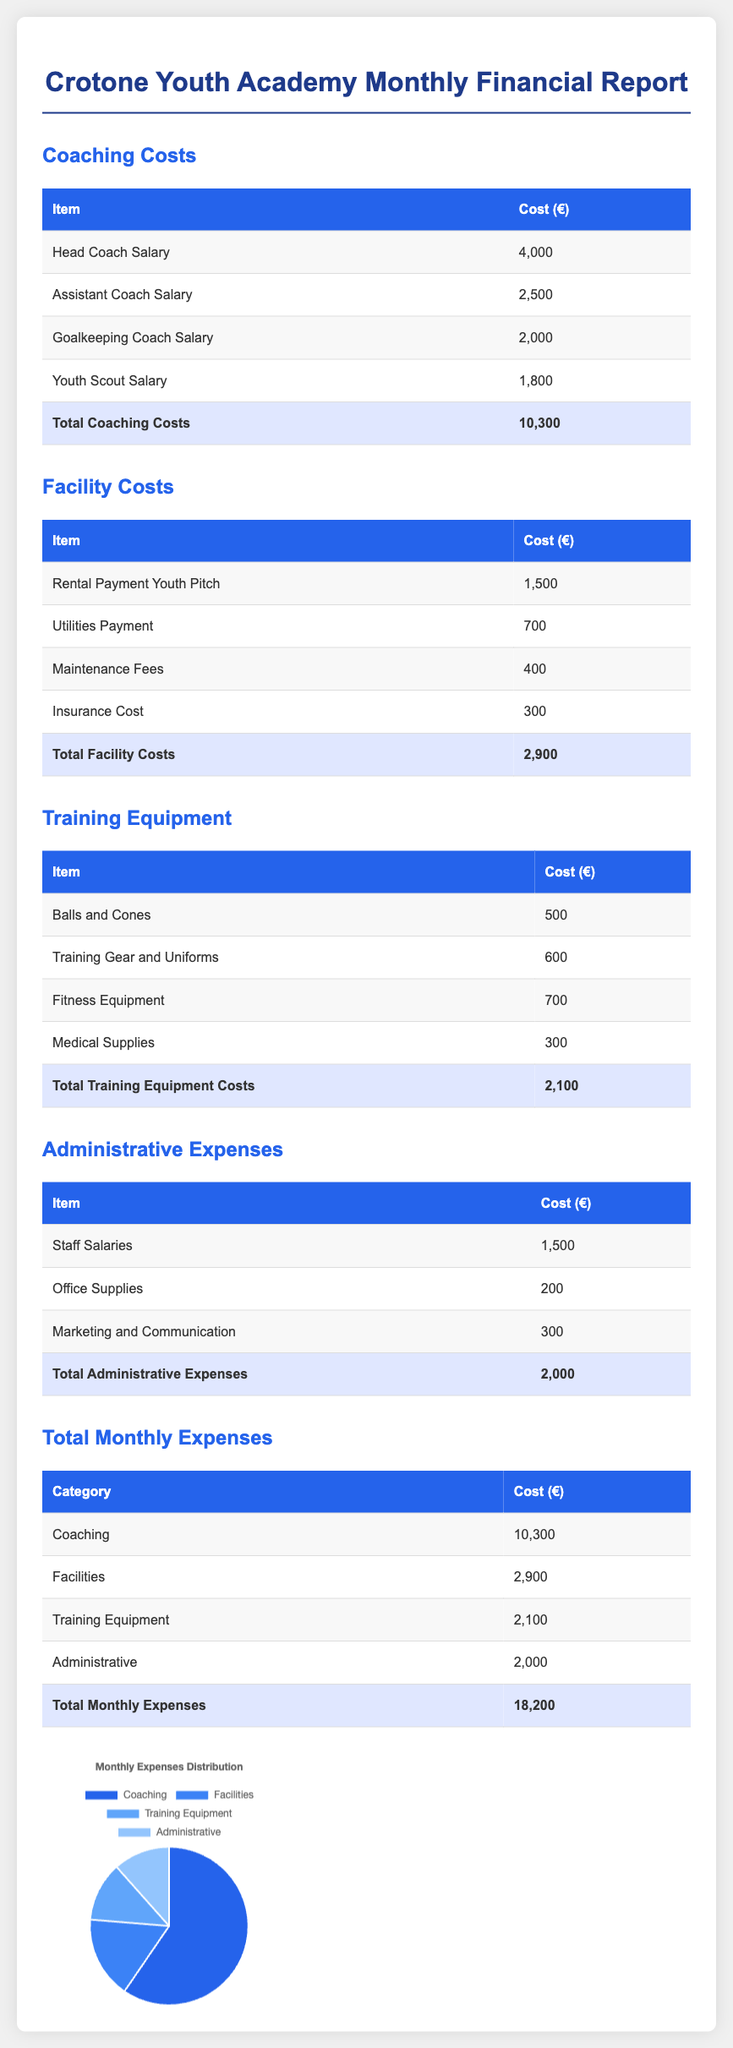What are the total coaching costs? The total coaching costs are detailed in the coaching costs section of the document, which lists all individual coaching expenses.
Answer: 10,300 What is the cost for the head coach's salary? The head coach's salary is listed under coaching costs, which specifically mentions the salary amount.
Answer: 4,000 How much does the youth academy spend on facilities? The total facility costs are summed up in the facilities section, providing the overall expense for facilities.
Answer: 2,900 What is the total cost for training equipment? The total training equipment costs are aggregated in the training equipment section, showing the overall expenditure.
Answer: 2,100 What are the total administrative expenses? The total administrative expenses are calculated in the administrative expenses section, summarizing individual costs listed there.
Answer: 2,000 What is the total monthly expense of the Crotone youth academy? The total monthly expenses are summarized in the final expenses table, listing all major expense categories cumulatively.
Answer: 18,200 Which category has the highest expenditure? The highest expenditure category is identified in the total monthly expenses table by comparing all listed costs.
Answer: Coaching What is the cost for medical supplies? The cost for medical supplies is specified in the training equipment section as an individual expense item.
Answer: 300 What percentage of the total expenses does coaching represent? This requires calculating from the total monthly expenses and coaching costs to derive the percentage representation.
Answer: 56.67% How many categories of expenses are presented in this report? The document lists different categories of expenses, which can be counted directly from the total expenses section.
Answer: 4 